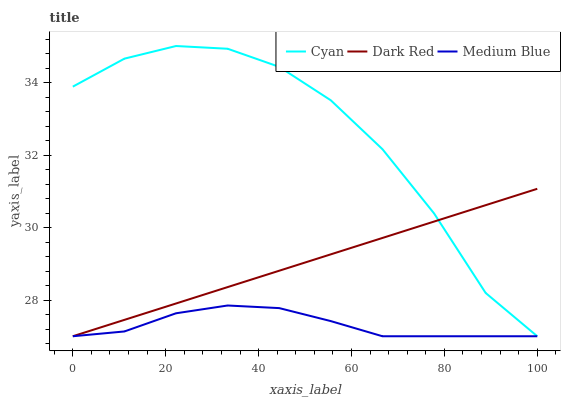Does Medium Blue have the minimum area under the curve?
Answer yes or no. Yes. Does Cyan have the maximum area under the curve?
Answer yes or no. Yes. Does Dark Red have the minimum area under the curve?
Answer yes or no. No. Does Dark Red have the maximum area under the curve?
Answer yes or no. No. Is Dark Red the smoothest?
Answer yes or no. Yes. Is Cyan the roughest?
Answer yes or no. Yes. Is Medium Blue the smoothest?
Answer yes or no. No. Is Medium Blue the roughest?
Answer yes or no. No. Does Cyan have the lowest value?
Answer yes or no. Yes. Does Cyan have the highest value?
Answer yes or no. Yes. Does Dark Red have the highest value?
Answer yes or no. No. Does Cyan intersect Medium Blue?
Answer yes or no. Yes. Is Cyan less than Medium Blue?
Answer yes or no. No. Is Cyan greater than Medium Blue?
Answer yes or no. No. 